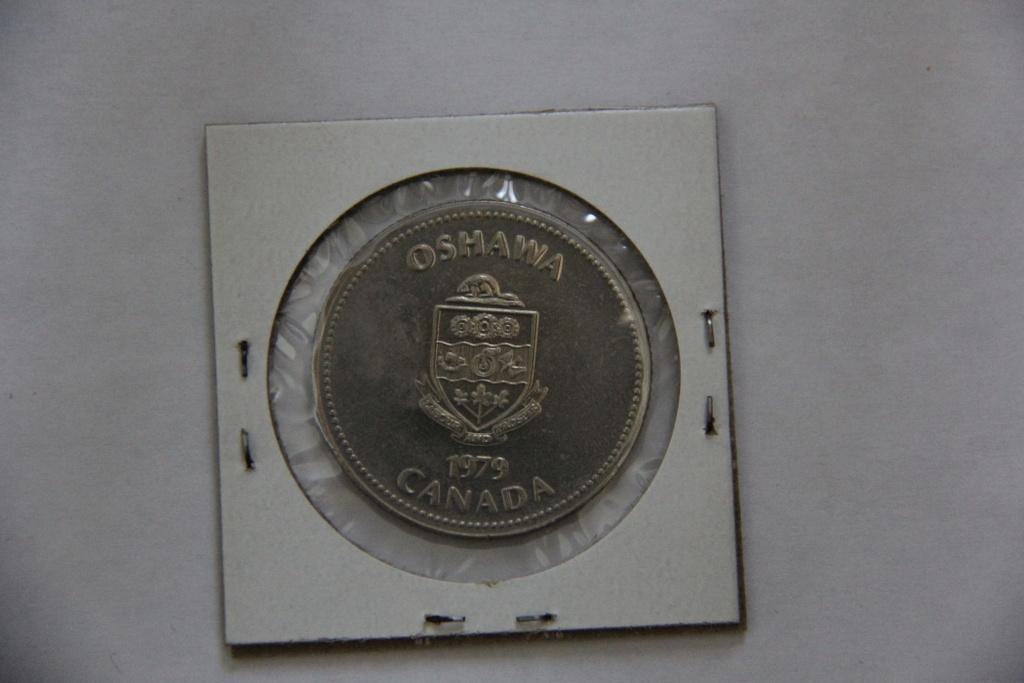<image>
Create a compact narrative representing the image presented. A collectors coin that reads Oshawa Canada 1979 is sealed to prevent damage. 